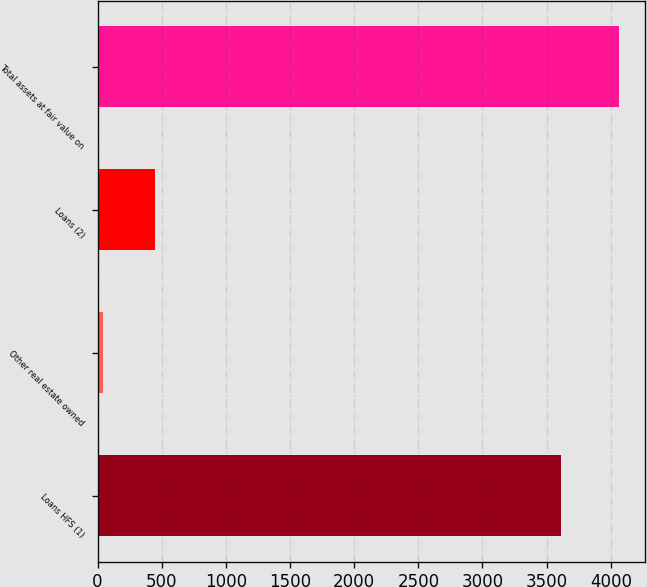<chart> <loc_0><loc_0><loc_500><loc_500><bar_chart><fcel>Loans HFS (1)<fcel>Other real estate owned<fcel>Loans (2)<fcel>Total assets at fair value on<nl><fcel>3609<fcel>44<fcel>446.3<fcel>4067<nl></chart> 